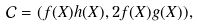<formula> <loc_0><loc_0><loc_500><loc_500>\mathcal { C } = ( f ( X ) h ( X ) , 2 f ( X ) g ( X ) ) ,</formula> 